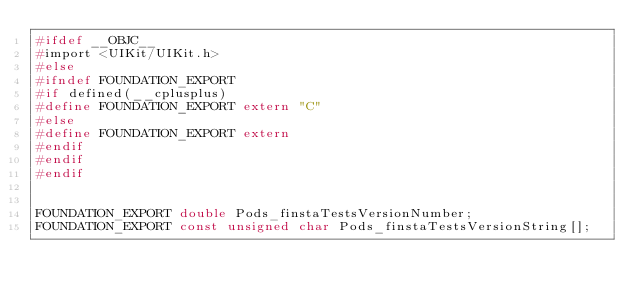<code> <loc_0><loc_0><loc_500><loc_500><_C_>#ifdef __OBJC__
#import <UIKit/UIKit.h>
#else
#ifndef FOUNDATION_EXPORT
#if defined(__cplusplus)
#define FOUNDATION_EXPORT extern "C"
#else
#define FOUNDATION_EXPORT extern
#endif
#endif
#endif


FOUNDATION_EXPORT double Pods_finstaTestsVersionNumber;
FOUNDATION_EXPORT const unsigned char Pods_finstaTestsVersionString[];

</code> 